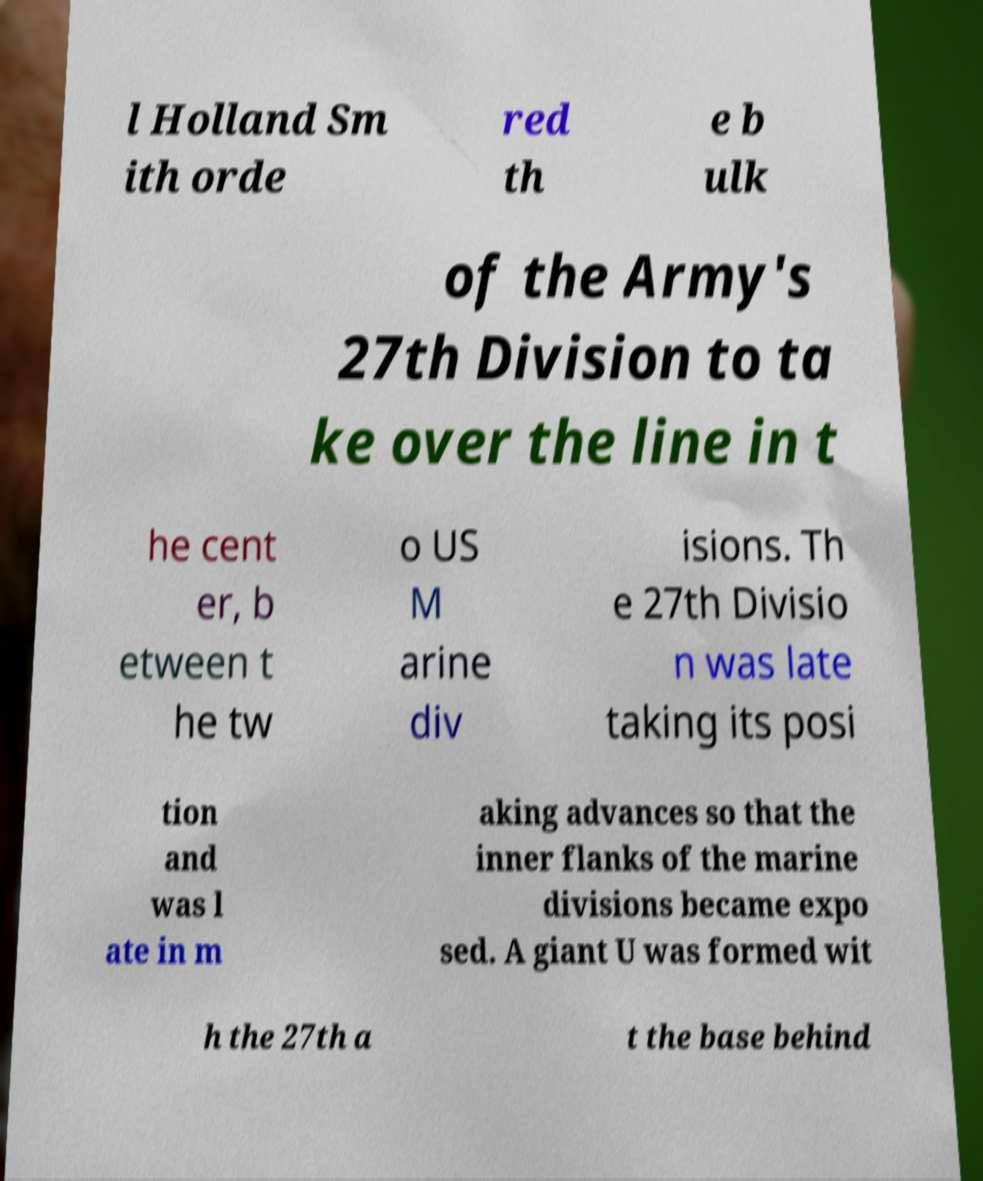I need the written content from this picture converted into text. Can you do that? l Holland Sm ith orde red th e b ulk of the Army's 27th Division to ta ke over the line in t he cent er, b etween t he tw o US M arine div isions. Th e 27th Divisio n was late taking its posi tion and was l ate in m aking advances so that the inner flanks of the marine divisions became expo sed. A giant U was formed wit h the 27th a t the base behind 